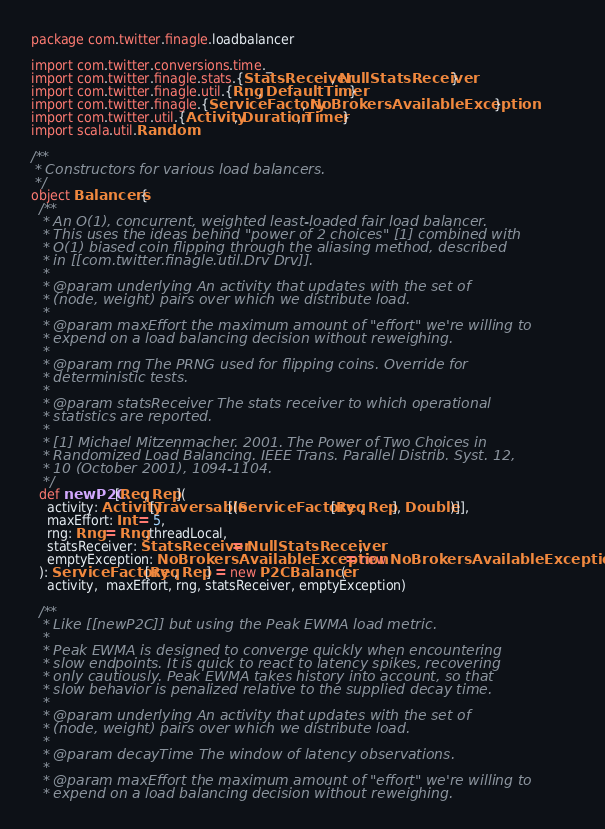Convert code to text. <code><loc_0><loc_0><loc_500><loc_500><_Scala_>package com.twitter.finagle.loadbalancer

import com.twitter.conversions.time._
import com.twitter.finagle.stats.{StatsReceiver, NullStatsReceiver}
import com.twitter.finagle.util.{Rng, DefaultTimer}
import com.twitter.finagle.{ServiceFactory, NoBrokersAvailableException}
import com.twitter.util.{Activity, Duration, Timer}
import scala.util.Random

/**
 * Constructors for various load balancers.
 */
object Balancers {
  /**
   * An O(1), concurrent, weighted least-loaded fair load balancer.
   * This uses the ideas behind "power of 2 choices" [1] combined with
   * O(1) biased coin flipping through the aliasing method, described
   * in [[com.twitter.finagle.util.Drv Drv]].
   *
   * @param underlying An activity that updates with the set of
   * (node, weight) pairs over which we distribute load.
   *
   * @param maxEffort the maximum amount of "effort" we're willing to
   * expend on a load balancing decision without reweighing.
   *
   * @param rng The PRNG used for flipping coins. Override for
   * deterministic tests.
   *
   * @param statsReceiver The stats receiver to which operational
   * statistics are reported.
   *
   * [1] Michael Mitzenmacher. 2001. The Power of Two Choices in
   * Randomized Load Balancing. IEEE Trans. Parallel Distrib. Syst. 12,
   * 10 (October 2001), 1094-1104.
   */
  def newP2C[Req, Rep](
    activity: Activity[Traversable[(ServiceFactory[Req, Rep], Double)]],
    maxEffort: Int = 5,
    rng: Rng = Rng.threadLocal,
    statsReceiver: StatsReceiver = NullStatsReceiver,
    emptyException: NoBrokersAvailableException = new NoBrokersAvailableException
  ): ServiceFactory[Req, Rep] = new P2CBalancer(
    activity,  maxEffort, rng, statsReceiver, emptyException)

  /**
   * Like [[newP2C]] but using the Peak EWMA load metric.
   *
   * Peak EWMA is designed to converge quickly when encountering
   * slow endpoints. It is quick to react to latency spikes, recovering
   * only cautiously. Peak EWMA takes history into account, so that 
   * slow behavior is penalized relative to the supplied decay time.
   *
   * @param underlying An activity that updates with the set of
   * (node, weight) pairs over which we distribute load.
   *
   * @param decayTime The window of latency observations.
   *
   * @param maxEffort the maximum amount of "effort" we're willing to
   * expend on a load balancing decision without reweighing.</code> 